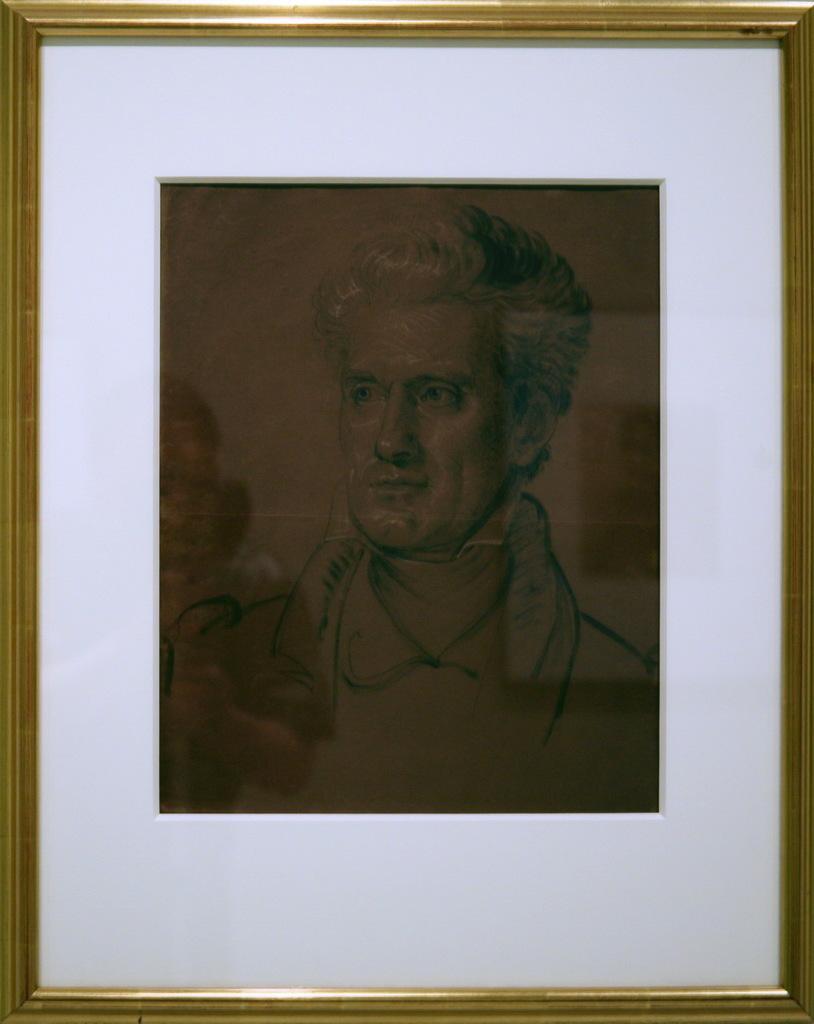In one or two sentences, can you explain what this image depicts? In this image I can see a photo frame. In this a man is looking at left side, the frame of this photo is in gold color. 